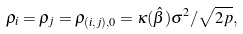Convert formula to latex. <formula><loc_0><loc_0><loc_500><loc_500>\rho _ { i } = \rho _ { j } = \rho _ { ( i , j ) , 0 } = \kappa ( \hat { \beta } ) \sigma ^ { 2 } / \sqrt { 2 p } ,</formula> 